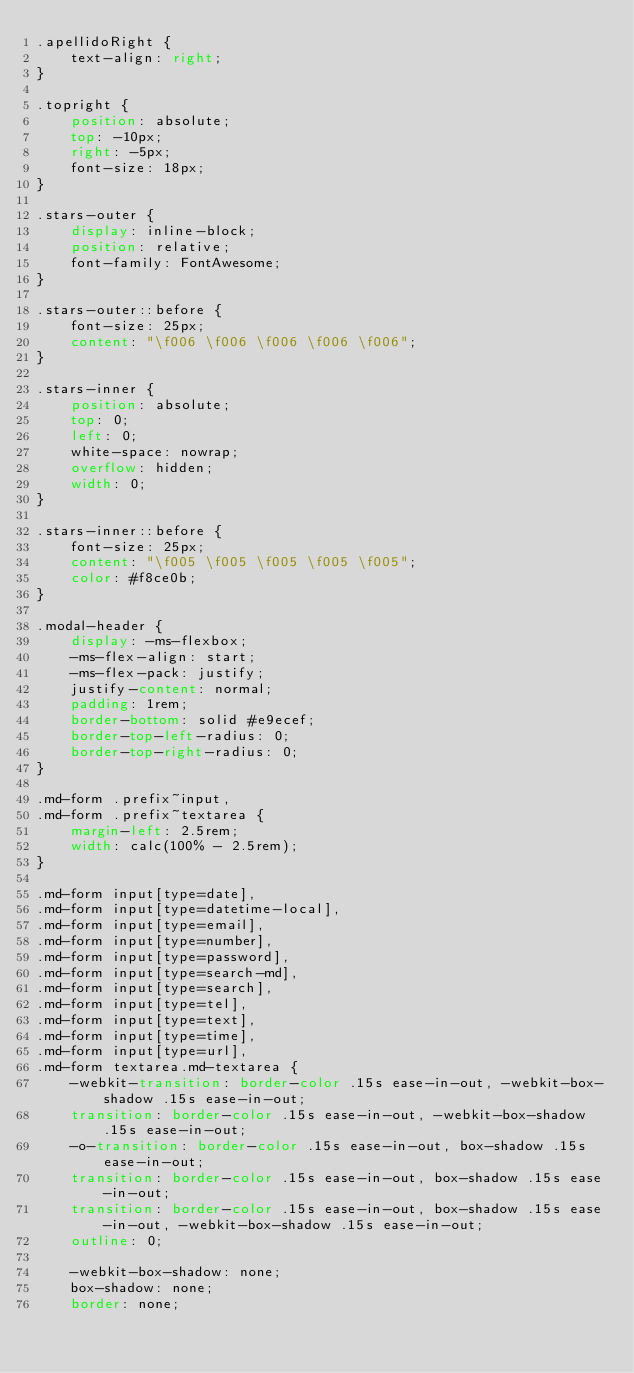<code> <loc_0><loc_0><loc_500><loc_500><_CSS_>.apellidoRight {
    text-align: right;
}

.topright {
    position: absolute;
    top: -10px;
    right: -5px;
    font-size: 18px;
}

.stars-outer {
    display: inline-block;
    position: relative;
    font-family: FontAwesome;
}

.stars-outer::before {
    font-size: 25px;
    content: "\f006 \f006 \f006 \f006 \f006";
}

.stars-inner {
    position: absolute;
    top: 0;
    left: 0;
    white-space: nowrap;
    overflow: hidden;
    width: 0;
}

.stars-inner::before {
    font-size: 25px;
    content: "\f005 \f005 \f005 \f005 \f005";
    color: #f8ce0b;
}

.modal-header {
    display: -ms-flexbox;
    -ms-flex-align: start;
    -ms-flex-pack: justify;
    justify-content: normal;
    padding: 1rem;
    border-bottom: solid #e9ecef;
    border-top-left-radius: 0;
    border-top-right-radius: 0;
}

.md-form .prefix~input,
.md-form .prefix~textarea {
    margin-left: 2.5rem;
    width: calc(100% - 2.5rem);
}

.md-form input[type=date],
.md-form input[type=datetime-local],
.md-form input[type=email],
.md-form input[type=number],
.md-form input[type=password],
.md-form input[type=search-md],
.md-form input[type=search],
.md-form input[type=tel],
.md-form input[type=text],
.md-form input[type=time],
.md-form input[type=url],
.md-form textarea.md-textarea {
    -webkit-transition: border-color .15s ease-in-out, -webkit-box-shadow .15s ease-in-out;
    transition: border-color .15s ease-in-out, -webkit-box-shadow .15s ease-in-out;
    -o-transition: border-color .15s ease-in-out, box-shadow .15s ease-in-out;
    transition: border-color .15s ease-in-out, box-shadow .15s ease-in-out;
    transition: border-color .15s ease-in-out, box-shadow .15s ease-in-out, -webkit-box-shadow .15s ease-in-out;
    outline: 0;

    -webkit-box-shadow: none;
    box-shadow: none;
    border: none;</code> 